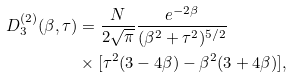Convert formula to latex. <formula><loc_0><loc_0><loc_500><loc_500>D ^ { ( 2 ) } _ { 3 } ( \beta , \tau ) & = \frac { N } { 2 \sqrt { \pi } } \frac { e ^ { - 2 \beta } } { ( \beta ^ { 2 } + \tau ^ { 2 } ) ^ { 5 / 2 } } \\ & \times [ \tau ^ { 2 } ( 3 - 4 \beta ) - \beta ^ { 2 } ( 3 + 4 \beta ) ] ,</formula> 